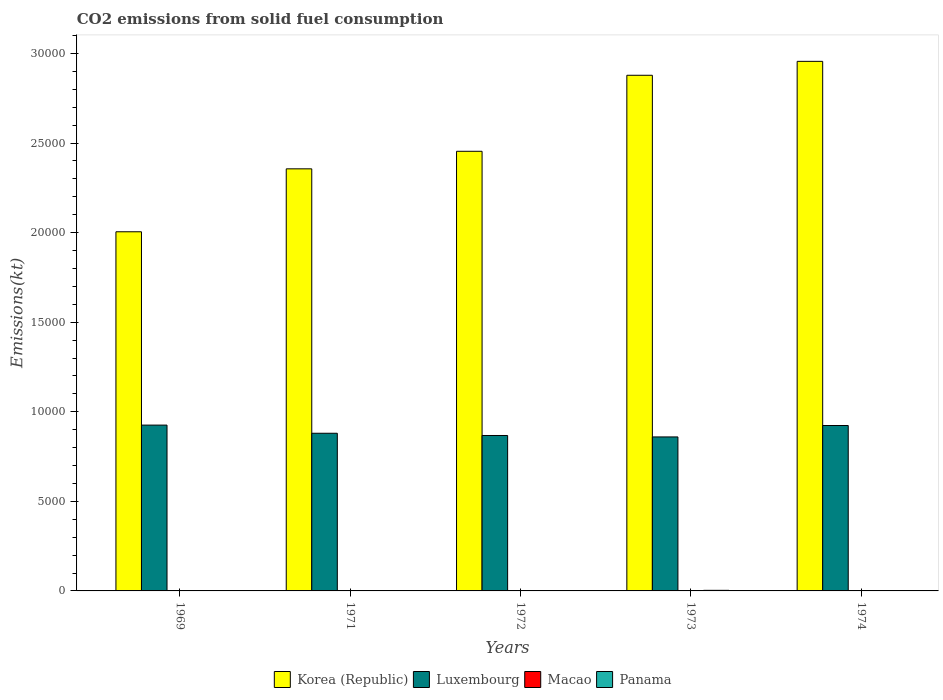Are the number of bars per tick equal to the number of legend labels?
Offer a terse response. Yes. How many bars are there on the 3rd tick from the right?
Make the answer very short. 4. What is the amount of CO2 emitted in Korea (Republic) in 1973?
Offer a very short reply. 2.88e+04. Across all years, what is the maximum amount of CO2 emitted in Panama?
Provide a short and direct response. 33. Across all years, what is the minimum amount of CO2 emitted in Korea (Republic)?
Provide a succinct answer. 2.00e+04. In which year was the amount of CO2 emitted in Macao maximum?
Give a very brief answer. 1969. In which year was the amount of CO2 emitted in Korea (Republic) minimum?
Your answer should be very brief. 1969. What is the total amount of CO2 emitted in Panama in the graph?
Your answer should be compact. 80.67. What is the difference between the amount of CO2 emitted in Korea (Republic) in 1969 and that in 1974?
Provide a succinct answer. -9512.2. What is the difference between the amount of CO2 emitted in Korea (Republic) in 1973 and the amount of CO2 emitted in Luxembourg in 1971?
Make the answer very short. 2.00e+04. What is the average amount of CO2 emitted in Macao per year?
Provide a short and direct response. 5.13. In the year 1973, what is the difference between the amount of CO2 emitted in Macao and amount of CO2 emitted in Panama?
Your answer should be very brief. -29.34. In how many years, is the amount of CO2 emitted in Korea (Republic) greater than 24000 kt?
Make the answer very short. 3. Is the difference between the amount of CO2 emitted in Macao in 1971 and 1974 greater than the difference between the amount of CO2 emitted in Panama in 1971 and 1974?
Offer a terse response. Yes. What is the difference between the highest and the second highest amount of CO2 emitted in Korea (Republic)?
Your answer should be compact. 777.4. What is the difference between the highest and the lowest amount of CO2 emitted in Macao?
Your answer should be compact. 3.67. In how many years, is the amount of CO2 emitted in Macao greater than the average amount of CO2 emitted in Macao taken over all years?
Offer a very short reply. 2. What does the 4th bar from the left in 1973 represents?
Give a very brief answer. Panama. What does the 1st bar from the right in 1969 represents?
Your answer should be compact. Panama. How many bars are there?
Your answer should be very brief. 20. How many years are there in the graph?
Your answer should be compact. 5. What is the difference between two consecutive major ticks on the Y-axis?
Provide a short and direct response. 5000. Are the values on the major ticks of Y-axis written in scientific E-notation?
Ensure brevity in your answer.  No. Does the graph contain any zero values?
Offer a very short reply. No. Does the graph contain grids?
Provide a short and direct response. No. How many legend labels are there?
Offer a terse response. 4. How are the legend labels stacked?
Your response must be concise. Horizontal. What is the title of the graph?
Provide a short and direct response. CO2 emissions from solid fuel consumption. Does "Vanuatu" appear as one of the legend labels in the graph?
Offer a very short reply. No. What is the label or title of the Y-axis?
Give a very brief answer. Emissions(kt). What is the Emissions(kt) of Korea (Republic) in 1969?
Your answer should be very brief. 2.00e+04. What is the Emissions(kt) of Luxembourg in 1969?
Keep it short and to the point. 9255.51. What is the Emissions(kt) in Macao in 1969?
Keep it short and to the point. 7.33. What is the Emissions(kt) of Panama in 1969?
Your answer should be very brief. 11. What is the Emissions(kt) of Korea (Republic) in 1971?
Your answer should be compact. 2.36e+04. What is the Emissions(kt) in Luxembourg in 1971?
Your response must be concise. 8800.8. What is the Emissions(kt) in Macao in 1971?
Provide a succinct answer. 7.33. What is the Emissions(kt) in Panama in 1971?
Offer a terse response. 3.67. What is the Emissions(kt) in Korea (Republic) in 1972?
Your answer should be compact. 2.45e+04. What is the Emissions(kt) of Luxembourg in 1972?
Offer a very short reply. 8676.12. What is the Emissions(kt) in Macao in 1972?
Make the answer very short. 3.67. What is the Emissions(kt) in Panama in 1972?
Give a very brief answer. 22. What is the Emissions(kt) of Korea (Republic) in 1973?
Your answer should be very brief. 2.88e+04. What is the Emissions(kt) in Luxembourg in 1973?
Your response must be concise. 8595.45. What is the Emissions(kt) of Macao in 1973?
Give a very brief answer. 3.67. What is the Emissions(kt) in Panama in 1973?
Offer a very short reply. 33. What is the Emissions(kt) in Korea (Republic) in 1974?
Keep it short and to the point. 2.96e+04. What is the Emissions(kt) of Luxembourg in 1974?
Your answer should be very brief. 9233.51. What is the Emissions(kt) in Macao in 1974?
Offer a very short reply. 3.67. What is the Emissions(kt) in Panama in 1974?
Make the answer very short. 11. Across all years, what is the maximum Emissions(kt) in Korea (Republic)?
Keep it short and to the point. 2.96e+04. Across all years, what is the maximum Emissions(kt) of Luxembourg?
Provide a succinct answer. 9255.51. Across all years, what is the maximum Emissions(kt) in Macao?
Keep it short and to the point. 7.33. Across all years, what is the maximum Emissions(kt) in Panama?
Your answer should be compact. 33. Across all years, what is the minimum Emissions(kt) in Korea (Republic)?
Make the answer very short. 2.00e+04. Across all years, what is the minimum Emissions(kt) in Luxembourg?
Provide a short and direct response. 8595.45. Across all years, what is the minimum Emissions(kt) in Macao?
Provide a succinct answer. 3.67. Across all years, what is the minimum Emissions(kt) of Panama?
Make the answer very short. 3.67. What is the total Emissions(kt) of Korea (Republic) in the graph?
Offer a terse response. 1.26e+05. What is the total Emissions(kt) of Luxembourg in the graph?
Your answer should be compact. 4.46e+04. What is the total Emissions(kt) in Macao in the graph?
Give a very brief answer. 25.67. What is the total Emissions(kt) in Panama in the graph?
Make the answer very short. 80.67. What is the difference between the Emissions(kt) of Korea (Republic) in 1969 and that in 1971?
Offer a very short reply. -3512.99. What is the difference between the Emissions(kt) in Luxembourg in 1969 and that in 1971?
Ensure brevity in your answer.  454.71. What is the difference between the Emissions(kt) of Panama in 1969 and that in 1971?
Provide a succinct answer. 7.33. What is the difference between the Emissions(kt) of Korea (Republic) in 1969 and that in 1972?
Your answer should be very brief. -4492.07. What is the difference between the Emissions(kt) in Luxembourg in 1969 and that in 1972?
Give a very brief answer. 579.39. What is the difference between the Emissions(kt) in Macao in 1969 and that in 1972?
Keep it short and to the point. 3.67. What is the difference between the Emissions(kt) of Panama in 1969 and that in 1972?
Offer a very short reply. -11. What is the difference between the Emissions(kt) of Korea (Republic) in 1969 and that in 1973?
Ensure brevity in your answer.  -8734.79. What is the difference between the Emissions(kt) of Luxembourg in 1969 and that in 1973?
Provide a short and direct response. 660.06. What is the difference between the Emissions(kt) in Macao in 1969 and that in 1973?
Make the answer very short. 3.67. What is the difference between the Emissions(kt) in Panama in 1969 and that in 1973?
Your response must be concise. -22. What is the difference between the Emissions(kt) in Korea (Republic) in 1969 and that in 1974?
Keep it short and to the point. -9512.2. What is the difference between the Emissions(kt) of Luxembourg in 1969 and that in 1974?
Offer a very short reply. 22. What is the difference between the Emissions(kt) of Macao in 1969 and that in 1974?
Your response must be concise. 3.67. What is the difference between the Emissions(kt) in Korea (Republic) in 1971 and that in 1972?
Your answer should be compact. -979.09. What is the difference between the Emissions(kt) of Luxembourg in 1971 and that in 1972?
Offer a very short reply. 124.68. What is the difference between the Emissions(kt) of Macao in 1971 and that in 1972?
Provide a succinct answer. 3.67. What is the difference between the Emissions(kt) in Panama in 1971 and that in 1972?
Offer a very short reply. -18.34. What is the difference between the Emissions(kt) of Korea (Republic) in 1971 and that in 1973?
Keep it short and to the point. -5221.81. What is the difference between the Emissions(kt) of Luxembourg in 1971 and that in 1973?
Keep it short and to the point. 205.35. What is the difference between the Emissions(kt) in Macao in 1971 and that in 1973?
Keep it short and to the point. 3.67. What is the difference between the Emissions(kt) in Panama in 1971 and that in 1973?
Your answer should be compact. -29.34. What is the difference between the Emissions(kt) of Korea (Republic) in 1971 and that in 1974?
Give a very brief answer. -5999.21. What is the difference between the Emissions(kt) in Luxembourg in 1971 and that in 1974?
Keep it short and to the point. -432.71. What is the difference between the Emissions(kt) in Macao in 1971 and that in 1974?
Give a very brief answer. 3.67. What is the difference between the Emissions(kt) of Panama in 1971 and that in 1974?
Your answer should be very brief. -7.33. What is the difference between the Emissions(kt) of Korea (Republic) in 1972 and that in 1973?
Your answer should be compact. -4242.72. What is the difference between the Emissions(kt) of Luxembourg in 1972 and that in 1973?
Your answer should be compact. 80.67. What is the difference between the Emissions(kt) in Panama in 1972 and that in 1973?
Keep it short and to the point. -11. What is the difference between the Emissions(kt) in Korea (Republic) in 1972 and that in 1974?
Give a very brief answer. -5020.12. What is the difference between the Emissions(kt) of Luxembourg in 1972 and that in 1974?
Offer a very short reply. -557.38. What is the difference between the Emissions(kt) in Macao in 1972 and that in 1974?
Provide a succinct answer. 0. What is the difference between the Emissions(kt) in Panama in 1972 and that in 1974?
Provide a short and direct response. 11. What is the difference between the Emissions(kt) of Korea (Republic) in 1973 and that in 1974?
Offer a terse response. -777.4. What is the difference between the Emissions(kt) in Luxembourg in 1973 and that in 1974?
Your answer should be compact. -638.06. What is the difference between the Emissions(kt) of Panama in 1973 and that in 1974?
Your answer should be very brief. 22. What is the difference between the Emissions(kt) in Korea (Republic) in 1969 and the Emissions(kt) in Luxembourg in 1971?
Keep it short and to the point. 1.12e+04. What is the difference between the Emissions(kt) in Korea (Republic) in 1969 and the Emissions(kt) in Macao in 1971?
Offer a very short reply. 2.00e+04. What is the difference between the Emissions(kt) of Korea (Republic) in 1969 and the Emissions(kt) of Panama in 1971?
Provide a succinct answer. 2.00e+04. What is the difference between the Emissions(kt) of Luxembourg in 1969 and the Emissions(kt) of Macao in 1971?
Offer a terse response. 9248.17. What is the difference between the Emissions(kt) in Luxembourg in 1969 and the Emissions(kt) in Panama in 1971?
Your response must be concise. 9251.84. What is the difference between the Emissions(kt) in Macao in 1969 and the Emissions(kt) in Panama in 1971?
Your answer should be compact. 3.67. What is the difference between the Emissions(kt) of Korea (Republic) in 1969 and the Emissions(kt) of Luxembourg in 1972?
Your answer should be very brief. 1.14e+04. What is the difference between the Emissions(kt) in Korea (Republic) in 1969 and the Emissions(kt) in Macao in 1972?
Your answer should be very brief. 2.00e+04. What is the difference between the Emissions(kt) of Korea (Republic) in 1969 and the Emissions(kt) of Panama in 1972?
Ensure brevity in your answer.  2.00e+04. What is the difference between the Emissions(kt) of Luxembourg in 1969 and the Emissions(kt) of Macao in 1972?
Ensure brevity in your answer.  9251.84. What is the difference between the Emissions(kt) of Luxembourg in 1969 and the Emissions(kt) of Panama in 1972?
Give a very brief answer. 9233.51. What is the difference between the Emissions(kt) of Macao in 1969 and the Emissions(kt) of Panama in 1972?
Give a very brief answer. -14.67. What is the difference between the Emissions(kt) of Korea (Republic) in 1969 and the Emissions(kt) of Luxembourg in 1973?
Give a very brief answer. 1.15e+04. What is the difference between the Emissions(kt) in Korea (Republic) in 1969 and the Emissions(kt) in Macao in 1973?
Provide a succinct answer. 2.00e+04. What is the difference between the Emissions(kt) in Korea (Republic) in 1969 and the Emissions(kt) in Panama in 1973?
Your answer should be compact. 2.00e+04. What is the difference between the Emissions(kt) in Luxembourg in 1969 and the Emissions(kt) in Macao in 1973?
Your response must be concise. 9251.84. What is the difference between the Emissions(kt) of Luxembourg in 1969 and the Emissions(kt) of Panama in 1973?
Your answer should be compact. 9222.5. What is the difference between the Emissions(kt) of Macao in 1969 and the Emissions(kt) of Panama in 1973?
Offer a terse response. -25.67. What is the difference between the Emissions(kt) in Korea (Republic) in 1969 and the Emissions(kt) in Luxembourg in 1974?
Give a very brief answer. 1.08e+04. What is the difference between the Emissions(kt) of Korea (Republic) in 1969 and the Emissions(kt) of Macao in 1974?
Provide a succinct answer. 2.00e+04. What is the difference between the Emissions(kt) of Korea (Republic) in 1969 and the Emissions(kt) of Panama in 1974?
Your response must be concise. 2.00e+04. What is the difference between the Emissions(kt) of Luxembourg in 1969 and the Emissions(kt) of Macao in 1974?
Provide a succinct answer. 9251.84. What is the difference between the Emissions(kt) in Luxembourg in 1969 and the Emissions(kt) in Panama in 1974?
Offer a very short reply. 9244.51. What is the difference between the Emissions(kt) in Macao in 1969 and the Emissions(kt) in Panama in 1974?
Ensure brevity in your answer.  -3.67. What is the difference between the Emissions(kt) in Korea (Republic) in 1971 and the Emissions(kt) in Luxembourg in 1972?
Offer a very short reply. 1.49e+04. What is the difference between the Emissions(kt) of Korea (Republic) in 1971 and the Emissions(kt) of Macao in 1972?
Offer a very short reply. 2.36e+04. What is the difference between the Emissions(kt) in Korea (Republic) in 1971 and the Emissions(kt) in Panama in 1972?
Keep it short and to the point. 2.35e+04. What is the difference between the Emissions(kt) in Luxembourg in 1971 and the Emissions(kt) in Macao in 1972?
Your response must be concise. 8797.13. What is the difference between the Emissions(kt) in Luxembourg in 1971 and the Emissions(kt) in Panama in 1972?
Give a very brief answer. 8778.8. What is the difference between the Emissions(kt) of Macao in 1971 and the Emissions(kt) of Panama in 1972?
Your answer should be compact. -14.67. What is the difference between the Emissions(kt) of Korea (Republic) in 1971 and the Emissions(kt) of Luxembourg in 1973?
Your response must be concise. 1.50e+04. What is the difference between the Emissions(kt) in Korea (Republic) in 1971 and the Emissions(kt) in Macao in 1973?
Provide a succinct answer. 2.36e+04. What is the difference between the Emissions(kt) of Korea (Republic) in 1971 and the Emissions(kt) of Panama in 1973?
Offer a terse response. 2.35e+04. What is the difference between the Emissions(kt) in Luxembourg in 1971 and the Emissions(kt) in Macao in 1973?
Provide a short and direct response. 8797.13. What is the difference between the Emissions(kt) in Luxembourg in 1971 and the Emissions(kt) in Panama in 1973?
Your answer should be compact. 8767.8. What is the difference between the Emissions(kt) of Macao in 1971 and the Emissions(kt) of Panama in 1973?
Provide a succinct answer. -25.67. What is the difference between the Emissions(kt) in Korea (Republic) in 1971 and the Emissions(kt) in Luxembourg in 1974?
Your answer should be very brief. 1.43e+04. What is the difference between the Emissions(kt) in Korea (Republic) in 1971 and the Emissions(kt) in Macao in 1974?
Your answer should be compact. 2.36e+04. What is the difference between the Emissions(kt) of Korea (Republic) in 1971 and the Emissions(kt) of Panama in 1974?
Make the answer very short. 2.35e+04. What is the difference between the Emissions(kt) of Luxembourg in 1971 and the Emissions(kt) of Macao in 1974?
Provide a succinct answer. 8797.13. What is the difference between the Emissions(kt) of Luxembourg in 1971 and the Emissions(kt) of Panama in 1974?
Give a very brief answer. 8789.8. What is the difference between the Emissions(kt) of Macao in 1971 and the Emissions(kt) of Panama in 1974?
Provide a succinct answer. -3.67. What is the difference between the Emissions(kt) of Korea (Republic) in 1972 and the Emissions(kt) of Luxembourg in 1973?
Your answer should be very brief. 1.59e+04. What is the difference between the Emissions(kt) of Korea (Republic) in 1972 and the Emissions(kt) of Macao in 1973?
Make the answer very short. 2.45e+04. What is the difference between the Emissions(kt) in Korea (Republic) in 1972 and the Emissions(kt) in Panama in 1973?
Offer a very short reply. 2.45e+04. What is the difference between the Emissions(kt) in Luxembourg in 1972 and the Emissions(kt) in Macao in 1973?
Give a very brief answer. 8672.45. What is the difference between the Emissions(kt) in Luxembourg in 1972 and the Emissions(kt) in Panama in 1973?
Give a very brief answer. 8643.12. What is the difference between the Emissions(kt) in Macao in 1972 and the Emissions(kt) in Panama in 1973?
Offer a very short reply. -29.34. What is the difference between the Emissions(kt) in Korea (Republic) in 1972 and the Emissions(kt) in Luxembourg in 1974?
Make the answer very short. 1.53e+04. What is the difference between the Emissions(kt) in Korea (Republic) in 1972 and the Emissions(kt) in Macao in 1974?
Your response must be concise. 2.45e+04. What is the difference between the Emissions(kt) of Korea (Republic) in 1972 and the Emissions(kt) of Panama in 1974?
Provide a succinct answer. 2.45e+04. What is the difference between the Emissions(kt) of Luxembourg in 1972 and the Emissions(kt) of Macao in 1974?
Your answer should be compact. 8672.45. What is the difference between the Emissions(kt) in Luxembourg in 1972 and the Emissions(kt) in Panama in 1974?
Make the answer very short. 8665.12. What is the difference between the Emissions(kt) in Macao in 1972 and the Emissions(kt) in Panama in 1974?
Keep it short and to the point. -7.33. What is the difference between the Emissions(kt) in Korea (Republic) in 1973 and the Emissions(kt) in Luxembourg in 1974?
Your answer should be very brief. 1.95e+04. What is the difference between the Emissions(kt) in Korea (Republic) in 1973 and the Emissions(kt) in Macao in 1974?
Provide a succinct answer. 2.88e+04. What is the difference between the Emissions(kt) in Korea (Republic) in 1973 and the Emissions(kt) in Panama in 1974?
Ensure brevity in your answer.  2.88e+04. What is the difference between the Emissions(kt) in Luxembourg in 1973 and the Emissions(kt) in Macao in 1974?
Keep it short and to the point. 8591.78. What is the difference between the Emissions(kt) in Luxembourg in 1973 and the Emissions(kt) in Panama in 1974?
Make the answer very short. 8584.45. What is the difference between the Emissions(kt) in Macao in 1973 and the Emissions(kt) in Panama in 1974?
Your response must be concise. -7.33. What is the average Emissions(kt) of Korea (Republic) per year?
Your answer should be very brief. 2.53e+04. What is the average Emissions(kt) in Luxembourg per year?
Provide a succinct answer. 8912.28. What is the average Emissions(kt) in Macao per year?
Your answer should be very brief. 5.13. What is the average Emissions(kt) in Panama per year?
Your answer should be very brief. 16.13. In the year 1969, what is the difference between the Emissions(kt) of Korea (Republic) and Emissions(kt) of Luxembourg?
Give a very brief answer. 1.08e+04. In the year 1969, what is the difference between the Emissions(kt) of Korea (Republic) and Emissions(kt) of Macao?
Provide a short and direct response. 2.00e+04. In the year 1969, what is the difference between the Emissions(kt) of Korea (Republic) and Emissions(kt) of Panama?
Ensure brevity in your answer.  2.00e+04. In the year 1969, what is the difference between the Emissions(kt) of Luxembourg and Emissions(kt) of Macao?
Keep it short and to the point. 9248.17. In the year 1969, what is the difference between the Emissions(kt) in Luxembourg and Emissions(kt) in Panama?
Ensure brevity in your answer.  9244.51. In the year 1969, what is the difference between the Emissions(kt) of Macao and Emissions(kt) of Panama?
Your response must be concise. -3.67. In the year 1971, what is the difference between the Emissions(kt) of Korea (Republic) and Emissions(kt) of Luxembourg?
Make the answer very short. 1.48e+04. In the year 1971, what is the difference between the Emissions(kt) in Korea (Republic) and Emissions(kt) in Macao?
Offer a very short reply. 2.36e+04. In the year 1971, what is the difference between the Emissions(kt) in Korea (Republic) and Emissions(kt) in Panama?
Keep it short and to the point. 2.36e+04. In the year 1971, what is the difference between the Emissions(kt) of Luxembourg and Emissions(kt) of Macao?
Offer a terse response. 8793.47. In the year 1971, what is the difference between the Emissions(kt) of Luxembourg and Emissions(kt) of Panama?
Ensure brevity in your answer.  8797.13. In the year 1971, what is the difference between the Emissions(kt) in Macao and Emissions(kt) in Panama?
Keep it short and to the point. 3.67. In the year 1972, what is the difference between the Emissions(kt) of Korea (Republic) and Emissions(kt) of Luxembourg?
Your response must be concise. 1.59e+04. In the year 1972, what is the difference between the Emissions(kt) of Korea (Republic) and Emissions(kt) of Macao?
Offer a very short reply. 2.45e+04. In the year 1972, what is the difference between the Emissions(kt) of Korea (Republic) and Emissions(kt) of Panama?
Keep it short and to the point. 2.45e+04. In the year 1972, what is the difference between the Emissions(kt) of Luxembourg and Emissions(kt) of Macao?
Offer a terse response. 8672.45. In the year 1972, what is the difference between the Emissions(kt) in Luxembourg and Emissions(kt) in Panama?
Your response must be concise. 8654.12. In the year 1972, what is the difference between the Emissions(kt) of Macao and Emissions(kt) of Panama?
Offer a terse response. -18.34. In the year 1973, what is the difference between the Emissions(kt) of Korea (Republic) and Emissions(kt) of Luxembourg?
Provide a short and direct response. 2.02e+04. In the year 1973, what is the difference between the Emissions(kt) in Korea (Republic) and Emissions(kt) in Macao?
Provide a succinct answer. 2.88e+04. In the year 1973, what is the difference between the Emissions(kt) of Korea (Republic) and Emissions(kt) of Panama?
Your answer should be very brief. 2.87e+04. In the year 1973, what is the difference between the Emissions(kt) of Luxembourg and Emissions(kt) of Macao?
Your answer should be compact. 8591.78. In the year 1973, what is the difference between the Emissions(kt) of Luxembourg and Emissions(kt) of Panama?
Provide a succinct answer. 8562.44. In the year 1973, what is the difference between the Emissions(kt) of Macao and Emissions(kt) of Panama?
Provide a short and direct response. -29.34. In the year 1974, what is the difference between the Emissions(kt) in Korea (Republic) and Emissions(kt) in Luxembourg?
Offer a terse response. 2.03e+04. In the year 1974, what is the difference between the Emissions(kt) in Korea (Republic) and Emissions(kt) in Macao?
Your answer should be compact. 2.96e+04. In the year 1974, what is the difference between the Emissions(kt) in Korea (Republic) and Emissions(kt) in Panama?
Provide a succinct answer. 2.95e+04. In the year 1974, what is the difference between the Emissions(kt) of Luxembourg and Emissions(kt) of Macao?
Your answer should be very brief. 9229.84. In the year 1974, what is the difference between the Emissions(kt) in Luxembourg and Emissions(kt) in Panama?
Ensure brevity in your answer.  9222.5. In the year 1974, what is the difference between the Emissions(kt) in Macao and Emissions(kt) in Panama?
Your answer should be very brief. -7.33. What is the ratio of the Emissions(kt) in Korea (Republic) in 1969 to that in 1971?
Offer a terse response. 0.85. What is the ratio of the Emissions(kt) in Luxembourg in 1969 to that in 1971?
Provide a short and direct response. 1.05. What is the ratio of the Emissions(kt) in Macao in 1969 to that in 1971?
Give a very brief answer. 1. What is the ratio of the Emissions(kt) in Panama in 1969 to that in 1971?
Offer a very short reply. 3. What is the ratio of the Emissions(kt) in Korea (Republic) in 1969 to that in 1972?
Keep it short and to the point. 0.82. What is the ratio of the Emissions(kt) of Luxembourg in 1969 to that in 1972?
Keep it short and to the point. 1.07. What is the ratio of the Emissions(kt) of Macao in 1969 to that in 1972?
Ensure brevity in your answer.  2. What is the ratio of the Emissions(kt) of Panama in 1969 to that in 1972?
Keep it short and to the point. 0.5. What is the ratio of the Emissions(kt) in Korea (Republic) in 1969 to that in 1973?
Offer a terse response. 0.7. What is the ratio of the Emissions(kt) in Luxembourg in 1969 to that in 1973?
Provide a succinct answer. 1.08. What is the ratio of the Emissions(kt) of Macao in 1969 to that in 1973?
Give a very brief answer. 2. What is the ratio of the Emissions(kt) of Panama in 1969 to that in 1973?
Your answer should be very brief. 0.33. What is the ratio of the Emissions(kt) of Korea (Republic) in 1969 to that in 1974?
Provide a short and direct response. 0.68. What is the ratio of the Emissions(kt) in Korea (Republic) in 1971 to that in 1972?
Provide a succinct answer. 0.96. What is the ratio of the Emissions(kt) of Luxembourg in 1971 to that in 1972?
Give a very brief answer. 1.01. What is the ratio of the Emissions(kt) of Macao in 1971 to that in 1972?
Ensure brevity in your answer.  2. What is the ratio of the Emissions(kt) in Korea (Republic) in 1971 to that in 1973?
Give a very brief answer. 0.82. What is the ratio of the Emissions(kt) in Luxembourg in 1971 to that in 1973?
Offer a terse response. 1.02. What is the ratio of the Emissions(kt) of Macao in 1971 to that in 1973?
Ensure brevity in your answer.  2. What is the ratio of the Emissions(kt) in Panama in 1971 to that in 1973?
Offer a very short reply. 0.11. What is the ratio of the Emissions(kt) in Korea (Republic) in 1971 to that in 1974?
Keep it short and to the point. 0.8. What is the ratio of the Emissions(kt) in Luxembourg in 1971 to that in 1974?
Offer a very short reply. 0.95. What is the ratio of the Emissions(kt) of Macao in 1971 to that in 1974?
Make the answer very short. 2. What is the ratio of the Emissions(kt) in Panama in 1971 to that in 1974?
Give a very brief answer. 0.33. What is the ratio of the Emissions(kt) in Korea (Republic) in 1972 to that in 1973?
Give a very brief answer. 0.85. What is the ratio of the Emissions(kt) in Luxembourg in 1972 to that in 1973?
Offer a very short reply. 1.01. What is the ratio of the Emissions(kt) in Macao in 1972 to that in 1973?
Your response must be concise. 1. What is the ratio of the Emissions(kt) of Korea (Republic) in 1972 to that in 1974?
Provide a short and direct response. 0.83. What is the ratio of the Emissions(kt) of Luxembourg in 1972 to that in 1974?
Your answer should be compact. 0.94. What is the ratio of the Emissions(kt) in Macao in 1972 to that in 1974?
Ensure brevity in your answer.  1. What is the ratio of the Emissions(kt) in Korea (Republic) in 1973 to that in 1974?
Your response must be concise. 0.97. What is the ratio of the Emissions(kt) of Luxembourg in 1973 to that in 1974?
Your response must be concise. 0.93. What is the ratio of the Emissions(kt) in Panama in 1973 to that in 1974?
Your response must be concise. 3. What is the difference between the highest and the second highest Emissions(kt) in Korea (Republic)?
Your answer should be compact. 777.4. What is the difference between the highest and the second highest Emissions(kt) in Luxembourg?
Ensure brevity in your answer.  22. What is the difference between the highest and the second highest Emissions(kt) in Macao?
Your response must be concise. 0. What is the difference between the highest and the second highest Emissions(kt) of Panama?
Provide a succinct answer. 11. What is the difference between the highest and the lowest Emissions(kt) in Korea (Republic)?
Your answer should be very brief. 9512.2. What is the difference between the highest and the lowest Emissions(kt) in Luxembourg?
Offer a very short reply. 660.06. What is the difference between the highest and the lowest Emissions(kt) of Macao?
Your response must be concise. 3.67. What is the difference between the highest and the lowest Emissions(kt) of Panama?
Keep it short and to the point. 29.34. 